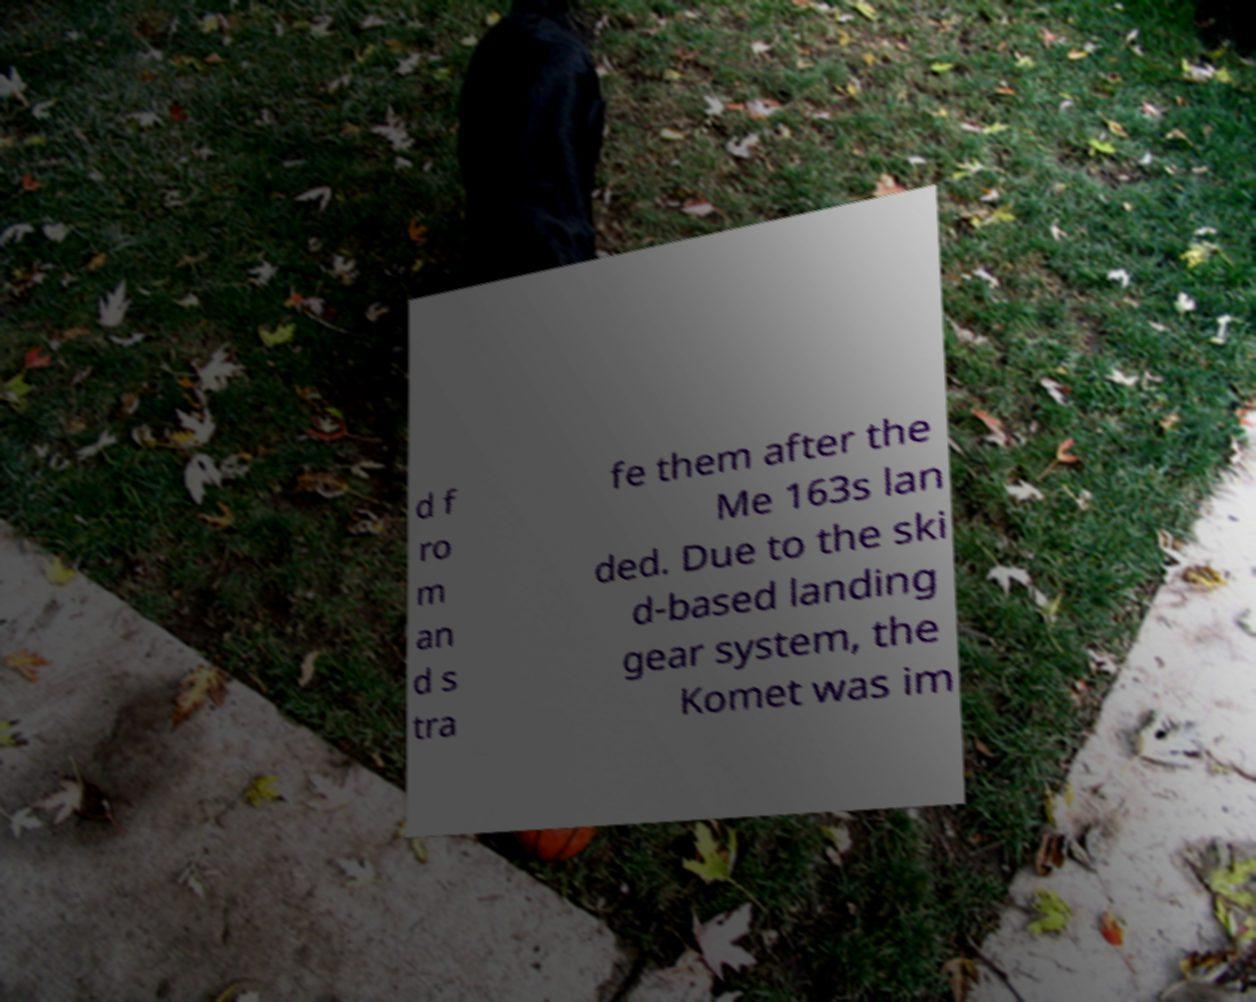For documentation purposes, I need the text within this image transcribed. Could you provide that? d f ro m an d s tra fe them after the Me 163s lan ded. Due to the ski d-based landing gear system, the Komet was im 